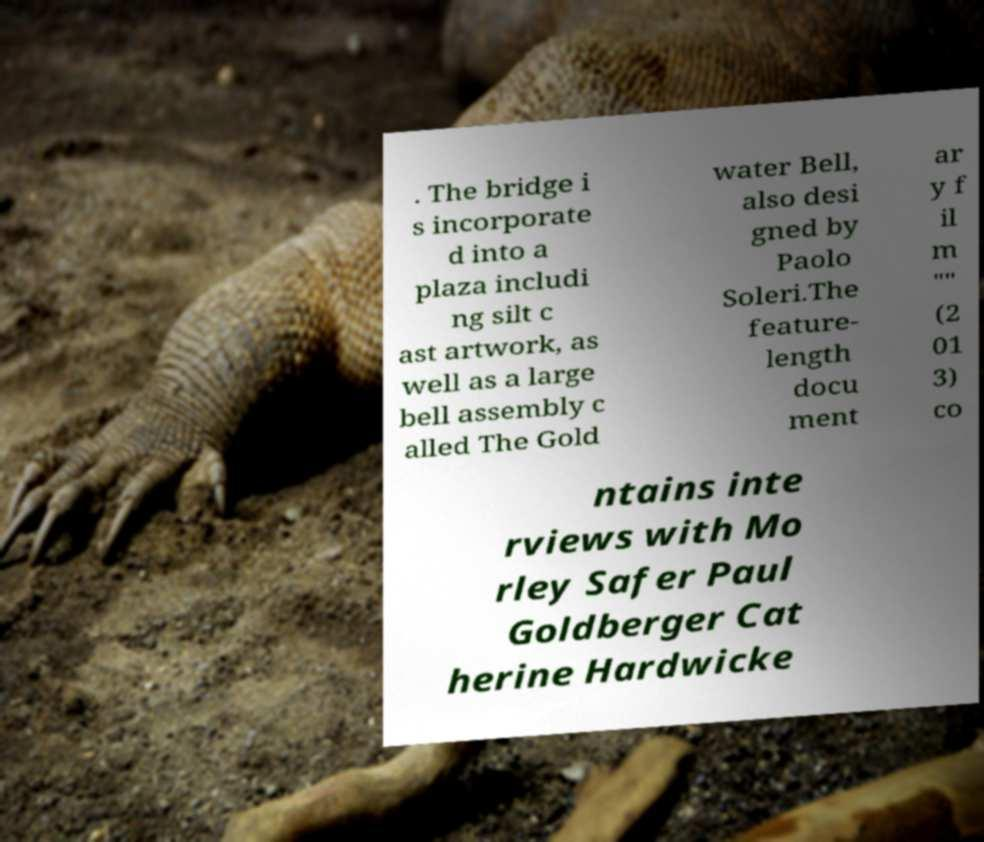Can you read and provide the text displayed in the image?This photo seems to have some interesting text. Can you extract and type it out for me? . The bridge i s incorporate d into a plaza includi ng silt c ast artwork, as well as a large bell assembly c alled The Gold water Bell, also desi gned by Paolo Soleri.The feature- length docu ment ar y f il m "" (2 01 3) co ntains inte rviews with Mo rley Safer Paul Goldberger Cat herine Hardwicke 